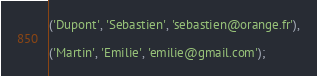<code> <loc_0><loc_0><loc_500><loc_500><_SQL_>
('Dupont', 'Sebastien', 'sebastien@orange.fr'),

('Martin', 'Emilie', 'emilie@gmail.com');</code> 